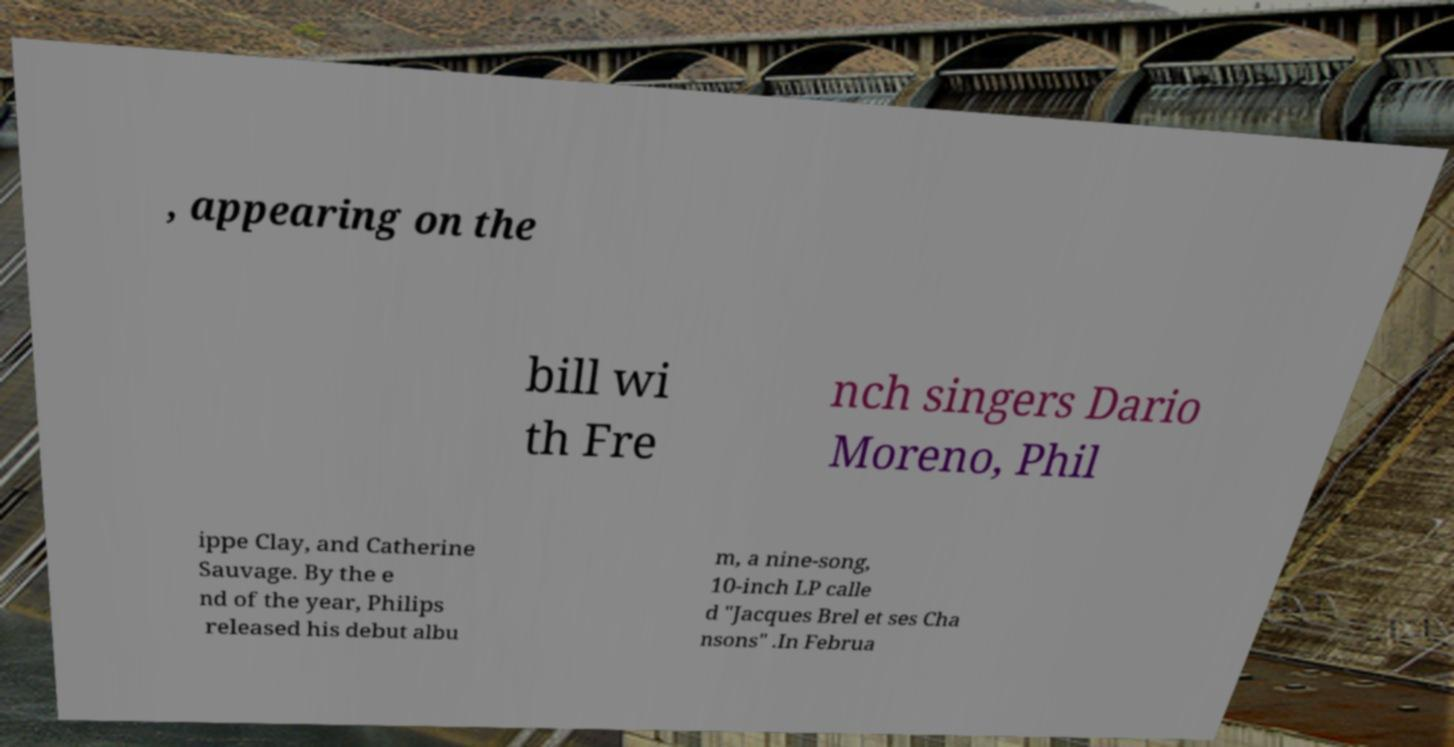Can you read and provide the text displayed in the image?This photo seems to have some interesting text. Can you extract and type it out for me? , appearing on the bill wi th Fre nch singers Dario Moreno, Phil ippe Clay, and Catherine Sauvage. By the e nd of the year, Philips released his debut albu m, a nine-song, 10-inch LP calle d "Jacques Brel et ses Cha nsons" .In Februa 